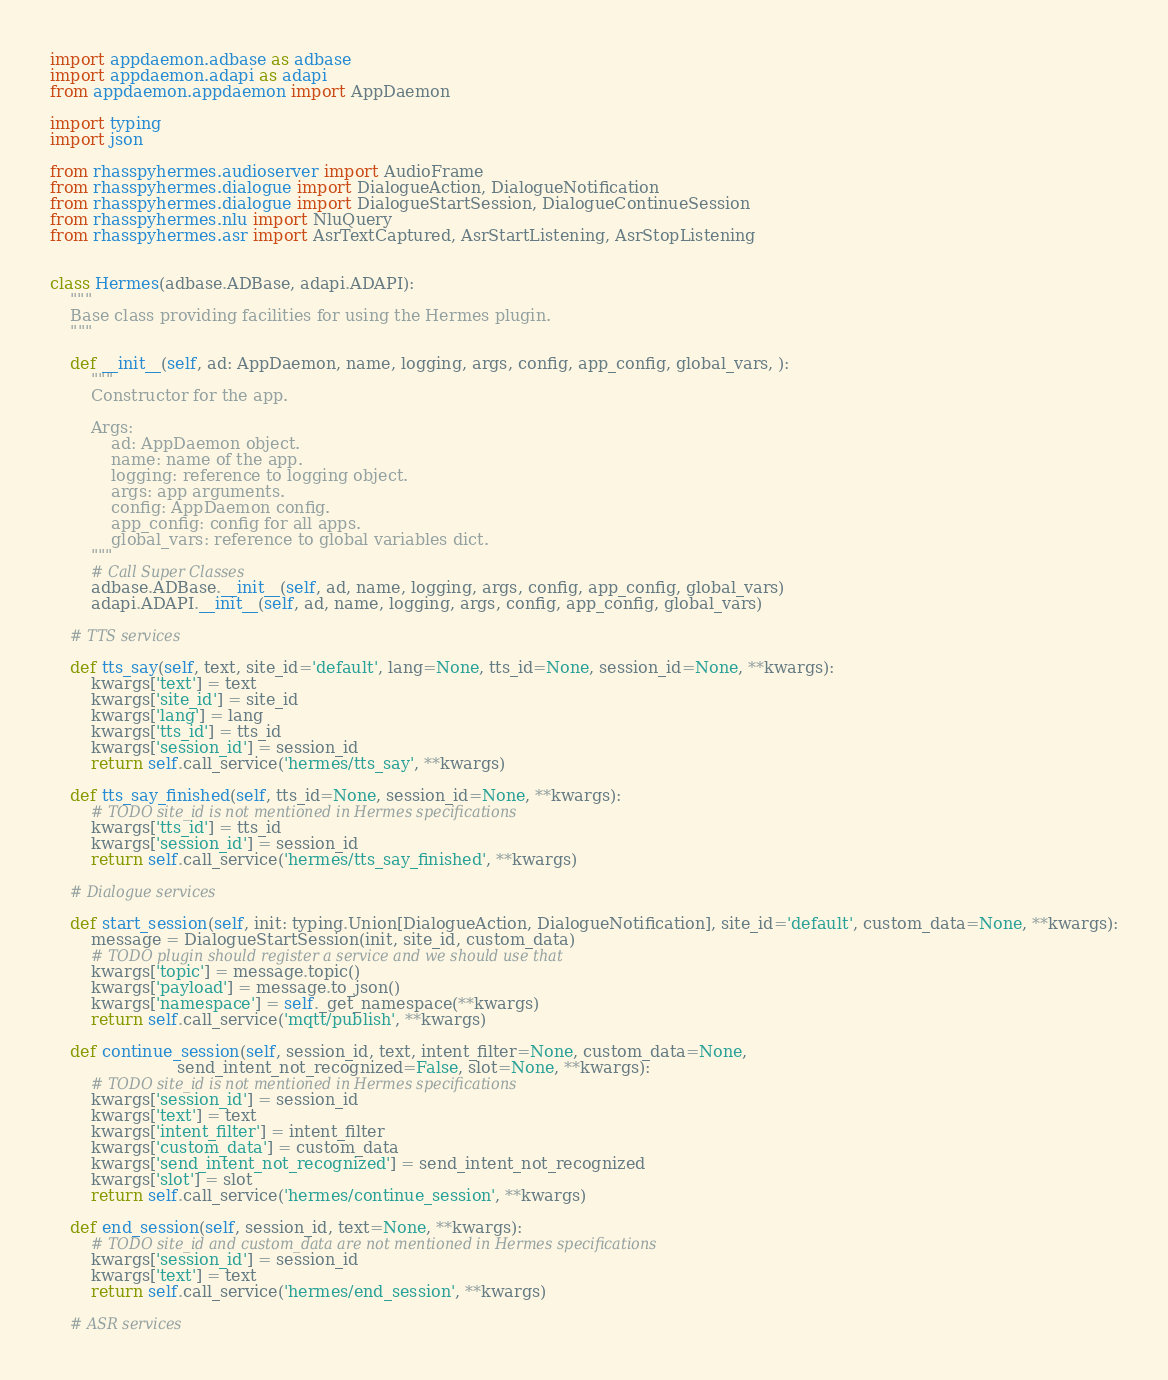<code> <loc_0><loc_0><loc_500><loc_500><_Python_>
import appdaemon.adbase as adbase
import appdaemon.adapi as adapi
from appdaemon.appdaemon import AppDaemon

import typing
import json

from rhasspyhermes.audioserver import AudioFrame
from rhasspyhermes.dialogue import DialogueAction, DialogueNotification
from rhasspyhermes.dialogue import DialogueStartSession, DialogueContinueSession
from rhasspyhermes.nlu import NluQuery
from rhasspyhermes.asr import AsrTextCaptured, AsrStartListening, AsrStopListening


class Hermes(adbase.ADBase, adapi.ADAPI):
    """
    Base class providing facilities for using the Hermes plugin.
    """

    def __init__(self, ad: AppDaemon, name, logging, args, config, app_config, global_vars, ):
        """
        Constructor for the app.

        Args:
            ad: AppDaemon object.
            name: name of the app.
            logging: reference to logging object.
            args: app arguments.
            config: AppDaemon config.
            app_config: config for all apps.
            global_vars: reference to global variables dict.
        """
        # Call Super Classes
        adbase.ADBase.__init__(self, ad, name, logging, args, config, app_config, global_vars)
        adapi.ADAPI.__init__(self, ad, name, logging, args, config, app_config, global_vars)

    # TTS services

    def tts_say(self, text, site_id='default', lang=None, tts_id=None, session_id=None, **kwargs):
        kwargs['text'] = text
        kwargs['site_id'] = site_id
        kwargs['lang'] = lang
        kwargs['tts_id'] = tts_id
        kwargs['session_id'] = session_id
        return self.call_service('hermes/tts_say', **kwargs)

    def tts_say_finished(self, tts_id=None, session_id=None, **kwargs):
        # TODO site_id is not mentioned in Hermes specifications
        kwargs['tts_id'] = tts_id
        kwargs['session_id'] = session_id
        return self.call_service('hermes/tts_say_finished', **kwargs)

    # Dialogue services

    def start_session(self, init: typing.Union[DialogueAction, DialogueNotification], site_id='default', custom_data=None, **kwargs):
        message = DialogueStartSession(init, site_id, custom_data)
        # TODO plugin should register a service and we should use that
        kwargs['topic'] = message.topic()
        kwargs['payload'] = message.to_json()
        kwargs['namespace'] = self._get_namespace(**kwargs)
        return self.call_service('mqtt/publish', **kwargs)

    def continue_session(self, session_id, text, intent_filter=None, custom_data=None,
                         send_intent_not_recognized=False, slot=None, **kwargs):
        # TODO site_id is not mentioned in Hermes specifications
        kwargs['session_id'] = session_id
        kwargs['text'] = text
        kwargs['intent_filter'] = intent_filter
        kwargs['custom_data'] = custom_data
        kwargs['send_intent_not_recognized'] = send_intent_not_recognized
        kwargs['slot'] = slot
        return self.call_service('hermes/continue_session', **kwargs)

    def end_session(self, session_id, text=None, **kwargs):
        # TODO site_id and custom_data are not mentioned in Hermes specifications
        kwargs['session_id'] = session_id
        kwargs['text'] = text
        return self.call_service('hermes/end_session', **kwargs)

    # ASR services
</code> 